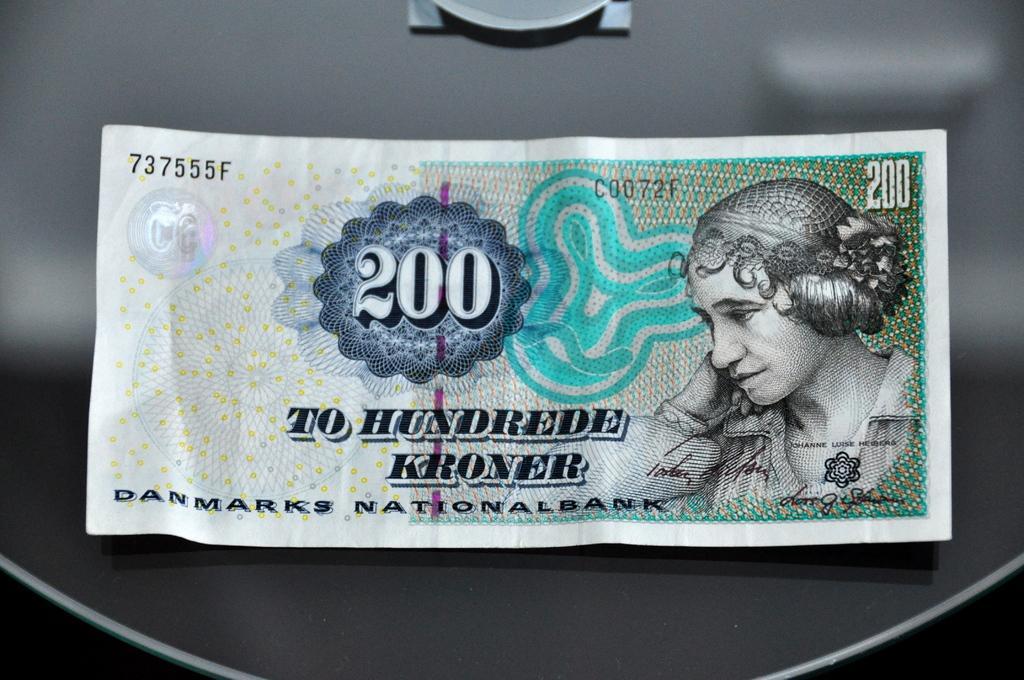Can you describe this image briefly? In this image there is a currency note kept on an object. 